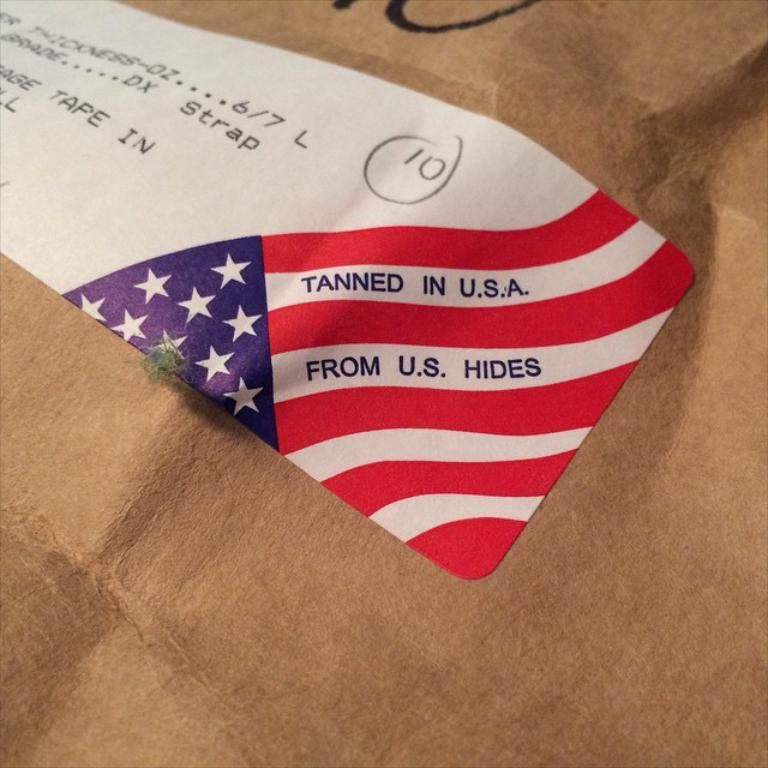<image>
Create a compact narrative representing the image presented. a label on a brown envelope that reads tanned in u.s.a. 